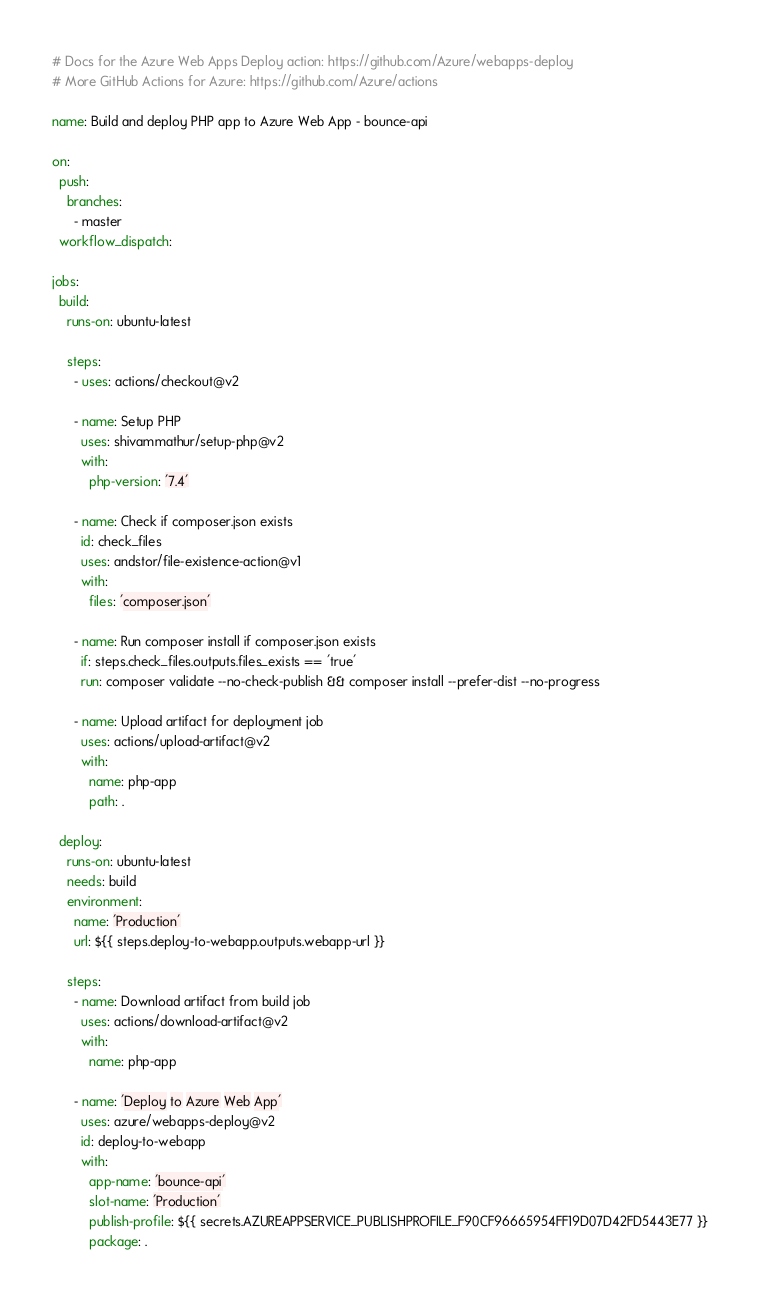Convert code to text. <code><loc_0><loc_0><loc_500><loc_500><_YAML_># Docs for the Azure Web Apps Deploy action: https://github.com/Azure/webapps-deploy
# More GitHub Actions for Azure: https://github.com/Azure/actions

name: Build and deploy PHP app to Azure Web App - bounce-api

on:
  push:
    branches:
      - master
  workflow_dispatch:

jobs:
  build:
    runs-on: ubuntu-latest

    steps:
      - uses: actions/checkout@v2

      - name: Setup PHP
        uses: shivammathur/setup-php@v2
        with:
          php-version: '7.4'

      - name: Check if composer.json exists
        id: check_files
        uses: andstor/file-existence-action@v1
        with:
          files: 'composer.json'

      - name: Run composer install if composer.json exists
        if: steps.check_files.outputs.files_exists == 'true'
        run: composer validate --no-check-publish && composer install --prefer-dist --no-progress

      - name: Upload artifact for deployment job
        uses: actions/upload-artifact@v2
        with:
          name: php-app
          path: .

  deploy:
    runs-on: ubuntu-latest
    needs: build
    environment:
      name: 'Production'
      url: ${{ steps.deploy-to-webapp.outputs.webapp-url }}

    steps:
      - name: Download artifact from build job
        uses: actions/download-artifact@v2
        with:
          name: php-app

      - name: 'Deploy to Azure Web App'
        uses: azure/webapps-deploy@v2
        id: deploy-to-webapp
        with:
          app-name: 'bounce-api'
          slot-name: 'Production'
          publish-profile: ${{ secrets.AZUREAPPSERVICE_PUBLISHPROFILE_F90CF96665954FF19D07D42FD5443E77 }}
          package: .
</code> 